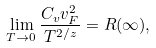Convert formula to latex. <formula><loc_0><loc_0><loc_500><loc_500>\lim _ { T \rightarrow 0 } \frac { C _ { v } v _ { F } ^ { 2 } } { T ^ { 2 / z } } = R ( \infty ) ,</formula> 